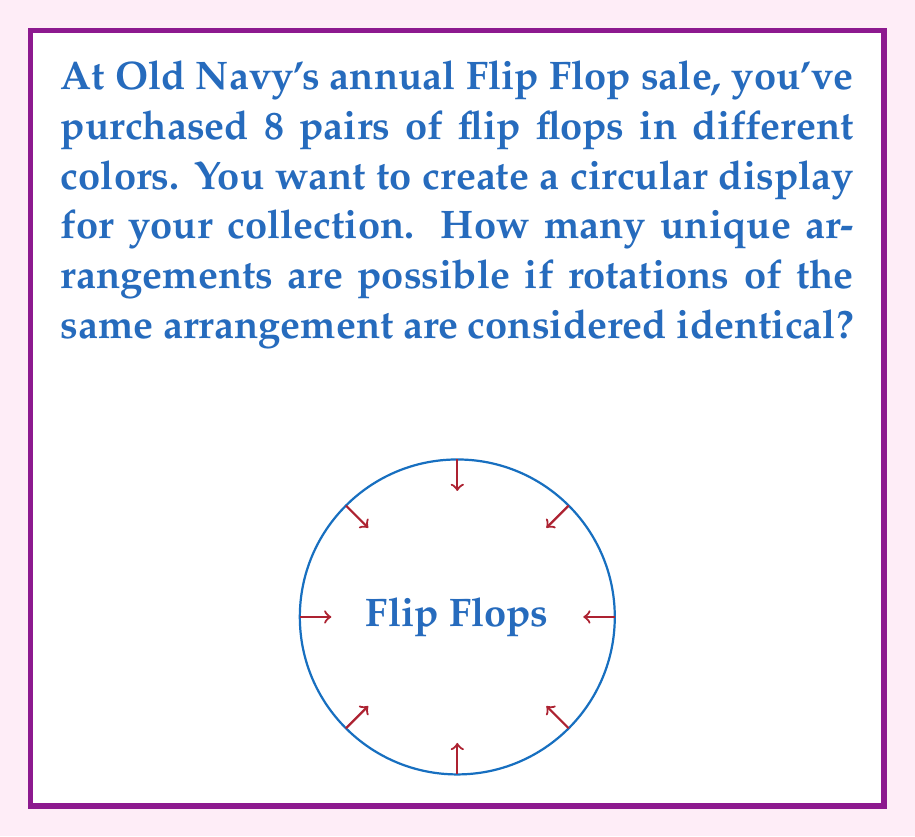Show me your answer to this math problem. Let's approach this step-by-step:

1) This problem is related to cyclic permutations in Ring theory.

2) We start with 8 distinct flip flops, which would normally give us 8! permutations.

3) However, since we're arranging them in a circle and rotations are considered identical, we need to account for this.

4) In a circular arrangement, each distinct arrangement can be rotated 8 ways to produce what we consider the same arrangement.

5) Therefore, we need to divide the total number of permutations by 8.

6) The formula for the number of unique circular permutations is:

   $$(n-1)!$$

   Where $n$ is the number of objects.

7) In this case, we have:

   $$(8-1)! = 7!$$

8) Let's calculate this:
   
   $$7! = 7 \times 6 \times 5 \times 4 \times 3 \times 2 \times 1 = 5040$$

Therefore, there are 5040 unique ways to arrange the 8 pairs of flip flops in a circular display.
Answer: 5040 